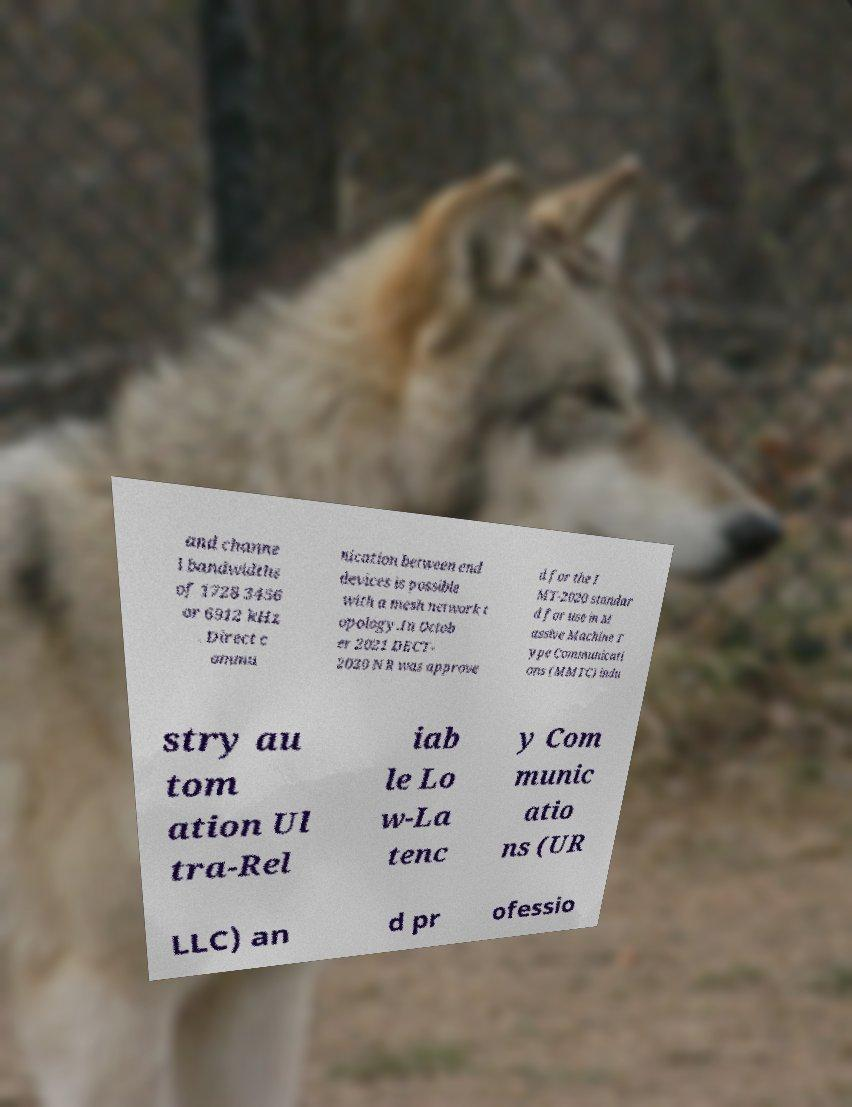What messages or text are displayed in this image? I need them in a readable, typed format. and channe l bandwidths of 1728 3456 or 6912 kHz . Direct c ommu nication between end devices is possible with a mesh network t opology.In Octob er 2021 DECT- 2020 NR was approve d for the I MT-2020 standar d for use in M assive Machine T ype Communicati ons (MMTC) indu stry au tom ation Ul tra-Rel iab le Lo w-La tenc y Com munic atio ns (UR LLC) an d pr ofessio 